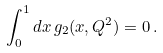Convert formula to latex. <formula><loc_0><loc_0><loc_500><loc_500>\int _ { 0 } ^ { 1 } d x \, g _ { 2 } ( x , Q ^ { 2 } ) = 0 \, .</formula> 